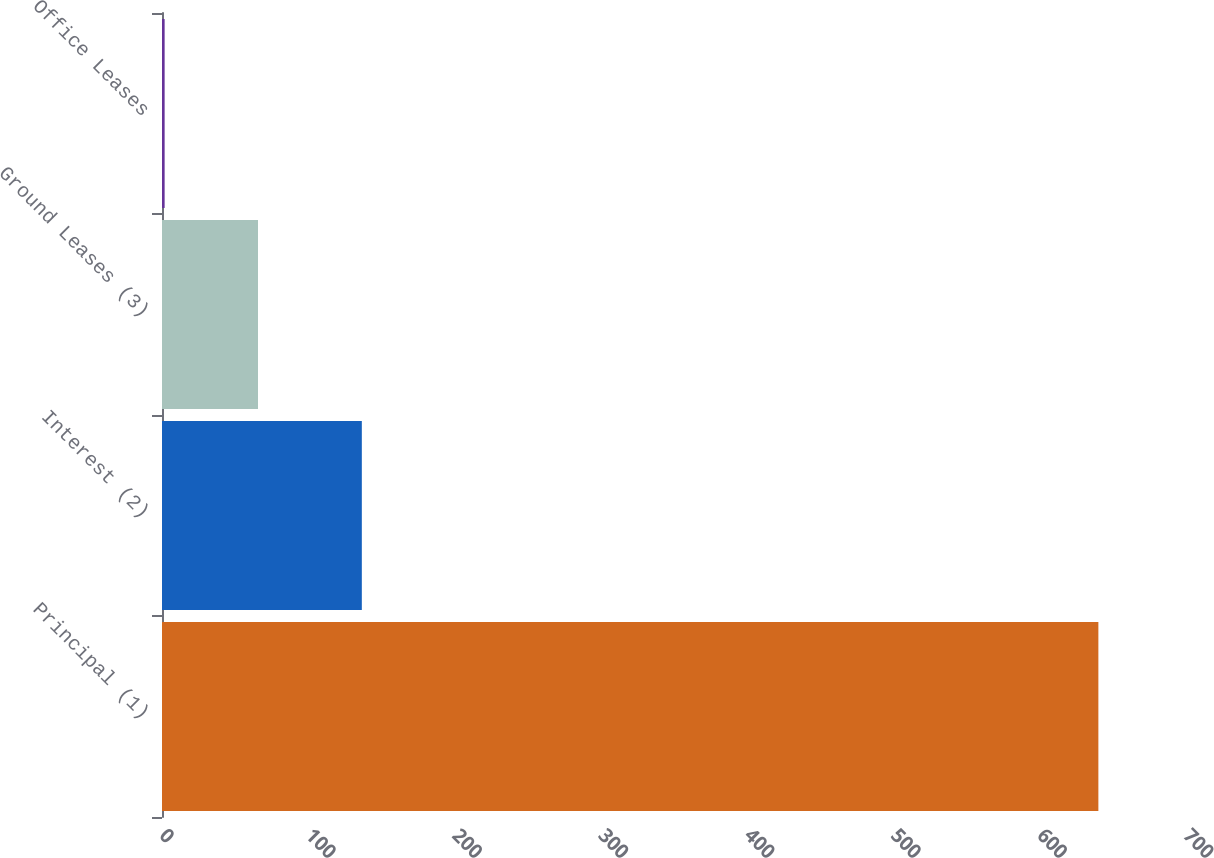Convert chart to OTSL. <chart><loc_0><loc_0><loc_500><loc_500><bar_chart><fcel>Principal (1)<fcel>Interest (2)<fcel>Ground Leases (3)<fcel>Office Leases<nl><fcel>640.1<fcel>136.6<fcel>65.63<fcel>1.8<nl></chart> 